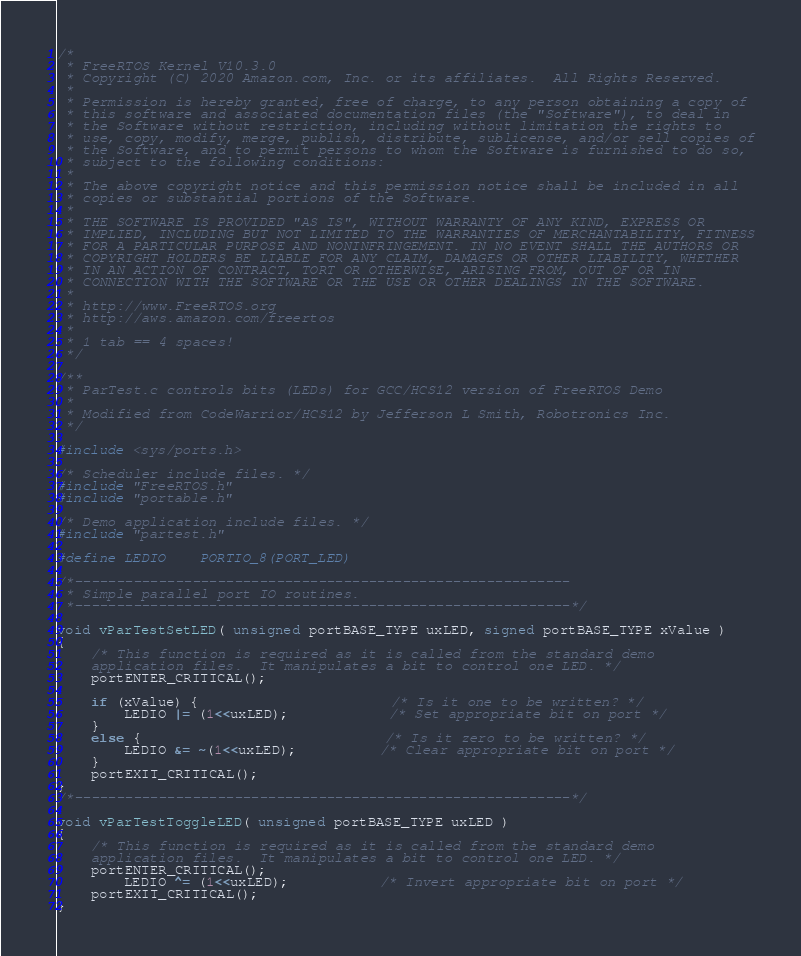Convert code to text. <code><loc_0><loc_0><loc_500><loc_500><_C_>/*
 * FreeRTOS Kernel V10.3.0
 * Copyright (C) 2020 Amazon.com, Inc. or its affiliates.  All Rights Reserved.
 *
 * Permission is hereby granted, free of charge, to any person obtaining a copy of
 * this software and associated documentation files (the "Software"), to deal in
 * the Software without restriction, including without limitation the rights to
 * use, copy, modify, merge, publish, distribute, sublicense, and/or sell copies of
 * the Software, and to permit persons to whom the Software is furnished to do so,
 * subject to the following conditions:
 *
 * The above copyright notice and this permission notice shall be included in all
 * copies or substantial portions of the Software.
 *
 * THE SOFTWARE IS PROVIDED "AS IS", WITHOUT WARRANTY OF ANY KIND, EXPRESS OR
 * IMPLIED, INCLUDING BUT NOT LIMITED TO THE WARRANTIES OF MERCHANTABILITY, FITNESS
 * FOR A PARTICULAR PURPOSE AND NONINFRINGEMENT. IN NO EVENT SHALL THE AUTHORS OR
 * COPYRIGHT HOLDERS BE LIABLE FOR ANY CLAIM, DAMAGES OR OTHER LIABILITY, WHETHER
 * IN AN ACTION OF CONTRACT, TORT OR OTHERWISE, ARISING FROM, OUT OF OR IN
 * CONNECTION WITH THE SOFTWARE OR THE USE OR OTHER DEALINGS IN THE SOFTWARE.
 *
 * http://www.FreeRTOS.org
 * http://aws.amazon.com/freertos
 *
 * 1 tab == 4 spaces!
 */

/** 
 * ParTest.c controls bits (LEDs) for GCC/HCS12 version of FreeRTOS Demo
 *
 * Modified from CodeWarrior/HCS12 by Jefferson L Smith, Robotronics Inc.
 */

#include <sys/ports.h>

/* Scheduler include files. */
#include "FreeRTOS.h"
#include "portable.h"

/* Demo application include files. */
#include "partest.h"

#define LEDIO	PORTIO_8(PORT_LED)

/*-----------------------------------------------------------
 * Simple parallel port IO routines.
 *-----------------------------------------------------------*/

void vParTestSetLED( unsigned portBASE_TYPE uxLED, signed portBASE_TYPE xValue )
{
	/* This function is required as it is called from the standard demo 
	application files.  It manipulates a bit to control one LED. */
	portENTER_CRITICAL();

	if (xValue) {                       /* Is it one to be written? */
		LEDIO |= (1<<uxLED);            /* Set appropriate bit on port */
	}
	else {                             /* Is it zero to be written? */
		LEDIO &= ~(1<<uxLED);          /* Clear appropriate bit on port */
	}
	portEXIT_CRITICAL();
}
/*-----------------------------------------------------------*/

void vParTestToggleLED( unsigned portBASE_TYPE uxLED )
{
	/* This function is required as it is called from the standard demo
	application files.  It manipulates a bit to control one LED. */
	portENTER_CRITICAL();
		LEDIO ^= (1<<uxLED);           /* Invert appropriate bit on port */
	portEXIT_CRITICAL();
}

</code> 